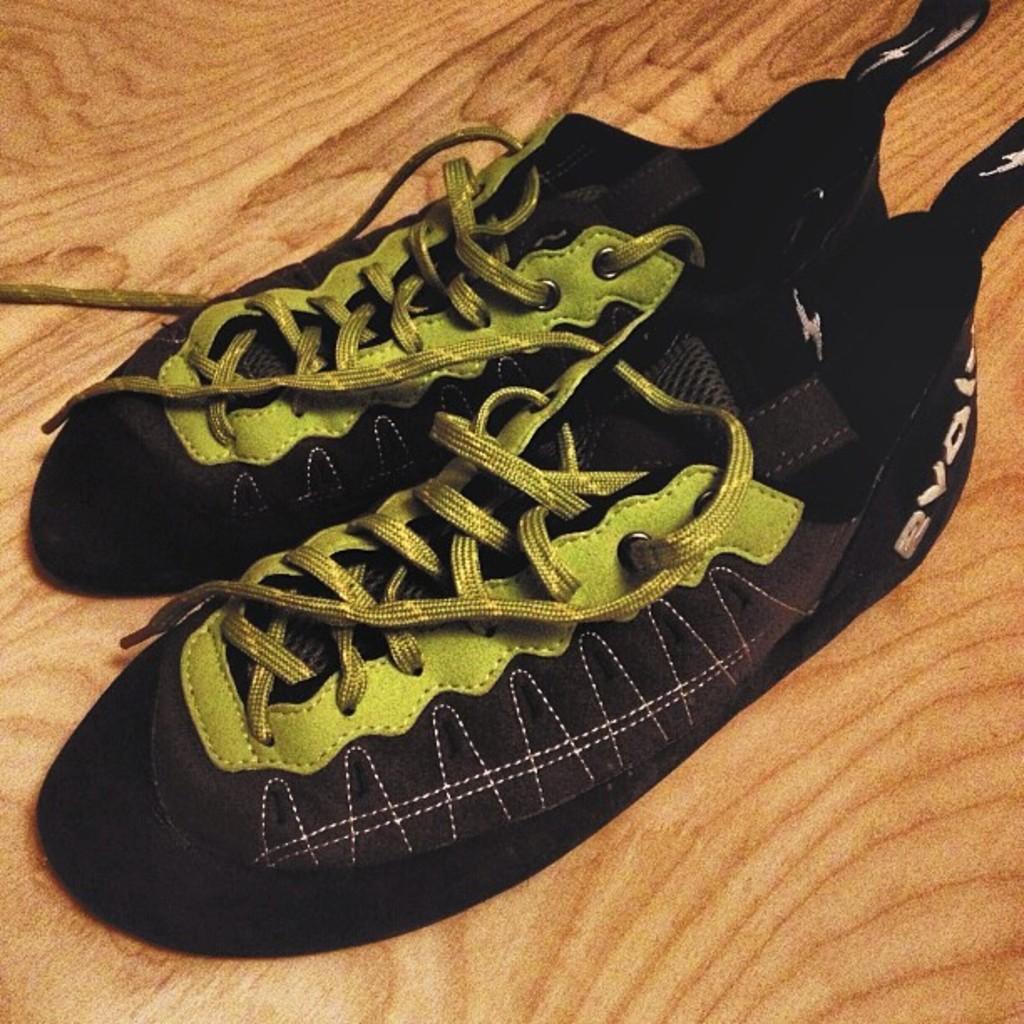Could you give a brief overview of what you see in this image? In this image I can see a pair of shoes on the wooden surface. 